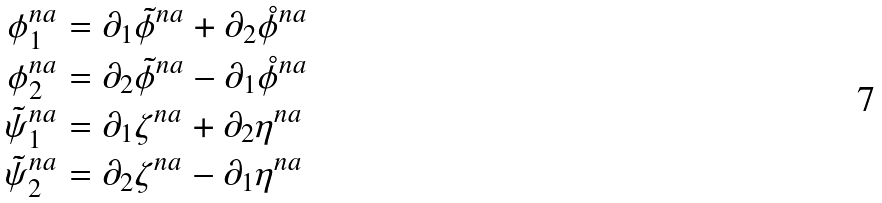Convert formula to latex. <formula><loc_0><loc_0><loc_500><loc_500>\phi ^ { n a } _ { 1 } & = \partial _ { 1 } \tilde { \phi } ^ { n a } + \partial _ { 2 } { \mathring { \phi } } ^ { n a } \\ \phi ^ { n a } _ { 2 } & = \partial _ { 2 } \tilde { \phi } ^ { n a } - \partial _ { 1 } { \mathring { \phi } } ^ { n a } \\ \tilde { \psi } ^ { n a } _ { 1 } & = \partial _ { 1 } \zeta ^ { n a } + \partial _ { 2 } \eta ^ { n a } \\ \tilde { \psi } ^ { n a } _ { 2 } & = \partial _ { 2 } \zeta ^ { n a } - \partial _ { 1 } \eta ^ { n a }</formula> 